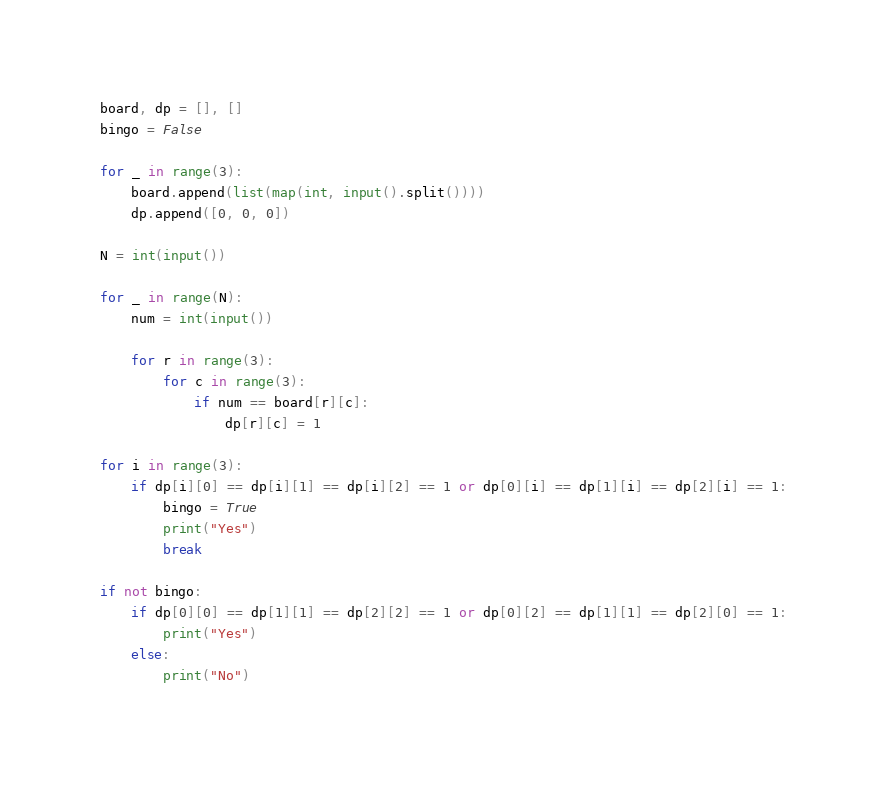<code> <loc_0><loc_0><loc_500><loc_500><_Python_>board, dp = [], []
bingo = False

for _ in range(3):
    board.append(list(map(int, input().split()))) 
    dp.append([0, 0, 0])

N = int(input())

for _ in range(N):
    num = int(input())

    for r in range(3):
        for c in range(3):
            if num == board[r][c]:
                dp[r][c] = 1

for i in range(3):
    if dp[i][0] == dp[i][1] == dp[i][2] == 1 or dp[0][i] == dp[1][i] == dp[2][i] == 1:
        bingo = True
        print("Yes")
        break

if not bingo:
    if dp[0][0] == dp[1][1] == dp[2][2] == 1 or dp[0][2] == dp[1][1] == dp[2][0] == 1:
        print("Yes")
    else:
        print("No")

</code> 